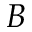<formula> <loc_0><loc_0><loc_500><loc_500>B</formula> 